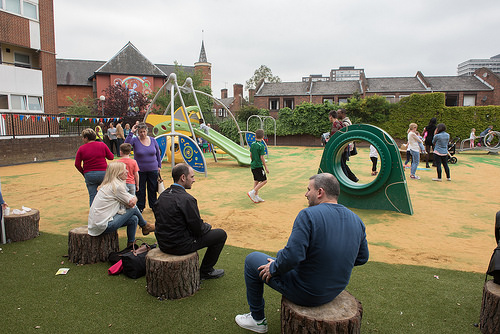<image>
Is the man in the jacket? Yes. The man is contained within or inside the jacket, showing a containment relationship. Where is the bag in relation to the person? Is it in front of the person? No. The bag is not in front of the person. The spatial positioning shows a different relationship between these objects. 